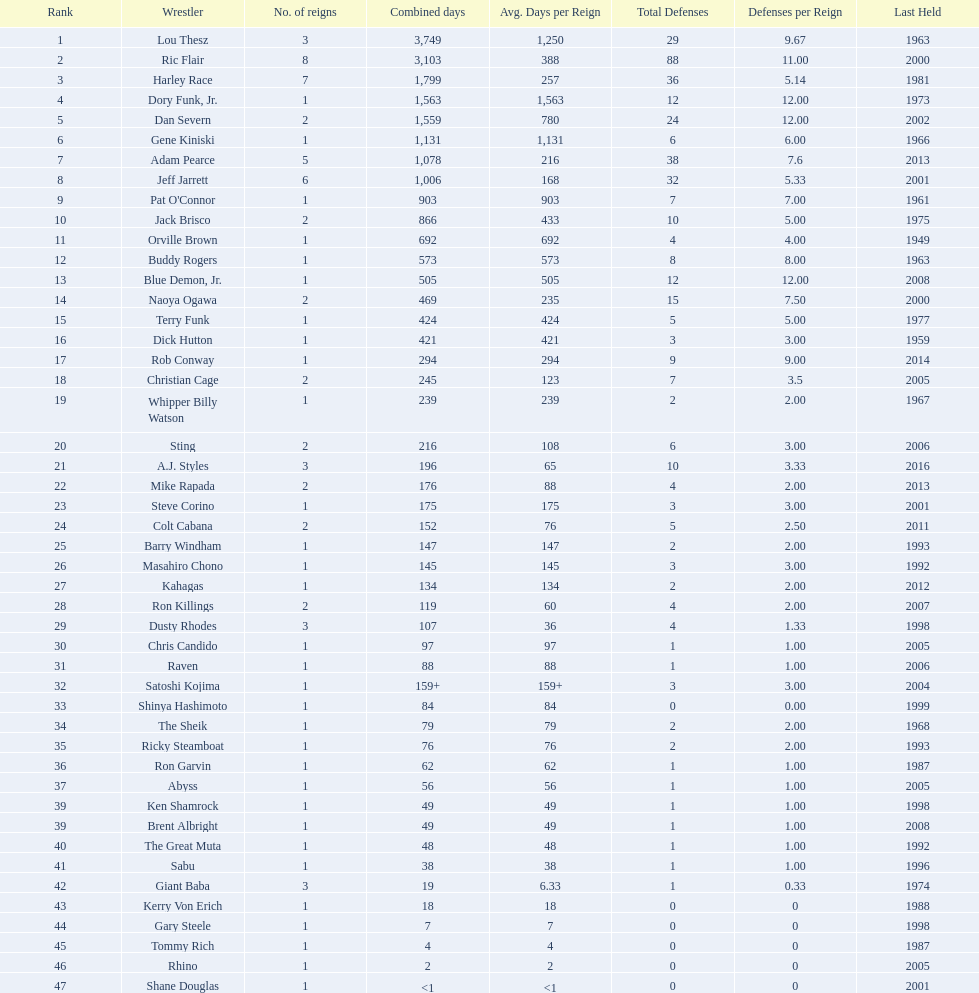Which professional wrestler has had the most number of reigns as nwa world heavyweight champion? Ric Flair. 